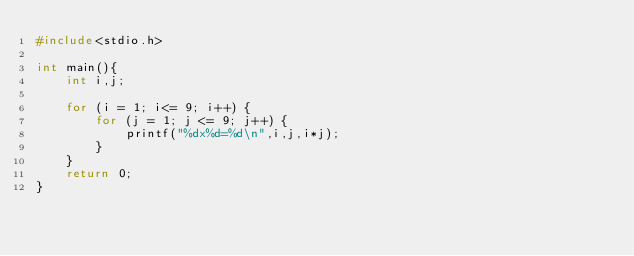<code> <loc_0><loc_0><loc_500><loc_500><_C_>#include<stdio.h>

int main(){
	int i,j;
	
	for (i = 1; i<= 9; i++) {
		for (j = 1; j <= 9; j++) {
			printf("%dx%d=%d\n",i,j,i*j);
		}
	}
    return 0;
}</code> 